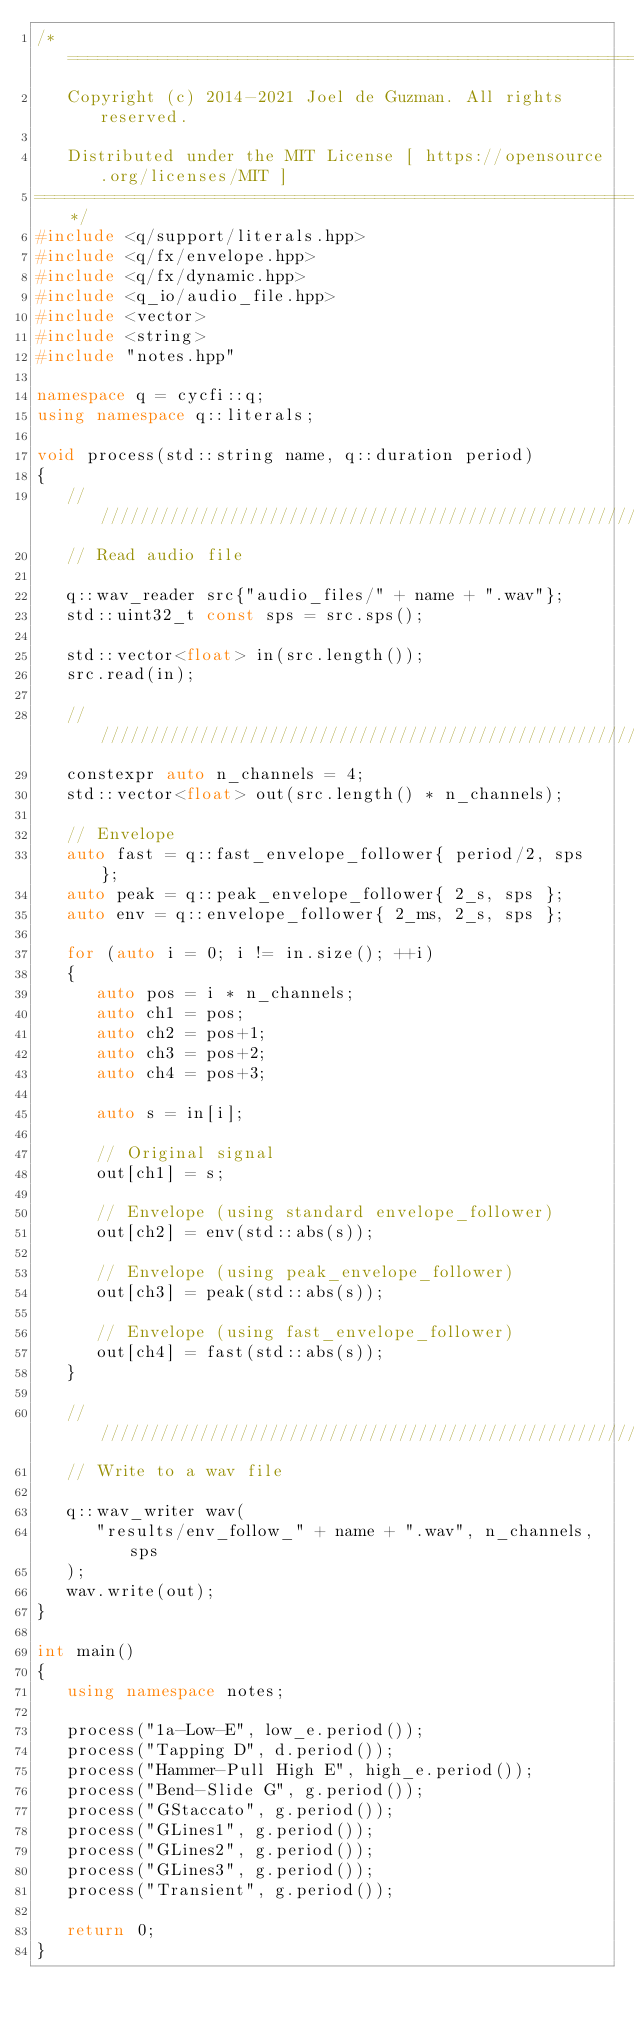Convert code to text. <code><loc_0><loc_0><loc_500><loc_500><_C++_>/*=============================================================================
   Copyright (c) 2014-2021 Joel de Guzman. All rights reserved.

   Distributed under the MIT License [ https://opensource.org/licenses/MIT ]
=============================================================================*/
#include <q/support/literals.hpp>
#include <q/fx/envelope.hpp>
#include <q/fx/dynamic.hpp>
#include <q_io/audio_file.hpp>
#include <vector>
#include <string>
#include "notes.hpp"

namespace q = cycfi::q;
using namespace q::literals;

void process(std::string name, q::duration period)
{
   ////////////////////////////////////////////////////////////////////////////
   // Read audio file

   q::wav_reader src{"audio_files/" + name + ".wav"};
   std::uint32_t const sps = src.sps();

   std::vector<float> in(src.length());
   src.read(in);

   ////////////////////////////////////////////////////////////////////////////
   constexpr auto n_channels = 4;
   std::vector<float> out(src.length() * n_channels);

   // Envelope
   auto fast = q::fast_envelope_follower{ period/2, sps };
   auto peak = q::peak_envelope_follower{ 2_s, sps };
   auto env = q::envelope_follower{ 2_ms, 2_s, sps };

   for (auto i = 0; i != in.size(); ++i)
   {
      auto pos = i * n_channels;
      auto ch1 = pos;
      auto ch2 = pos+1;
      auto ch3 = pos+2;
      auto ch4 = pos+3;

      auto s = in[i];

      // Original signal
      out[ch1] = s;

      // Envelope (using standard envelope_follower)
      out[ch2] = env(std::abs(s));

      // Envelope (using peak_envelope_follower)
      out[ch3] = peak(std::abs(s));

      // Envelope (using fast_envelope_follower)
      out[ch4] = fast(std::abs(s));
   }

   ////////////////////////////////////////////////////////////////////////////
   // Write to a wav file

   q::wav_writer wav(
      "results/env_follow_" + name + ".wav", n_channels, sps
   );
   wav.write(out);
}

int main()
{
   using namespace notes;

   process("1a-Low-E", low_e.period());
   process("Tapping D", d.period());
   process("Hammer-Pull High E", high_e.period());
   process("Bend-Slide G", g.period());
   process("GStaccato", g.period());
   process("GLines1", g.period());
   process("GLines2", g.period());
   process("GLines3", g.period());
   process("Transient", g.period());

   return 0;
}</code> 